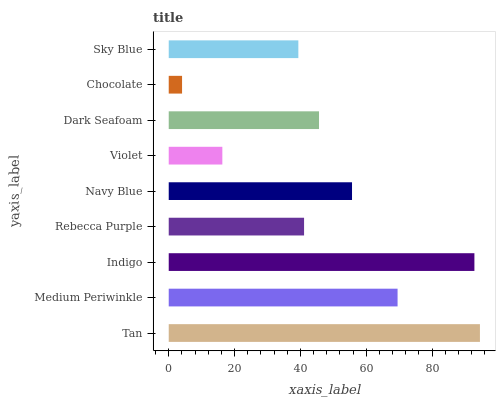Is Chocolate the minimum?
Answer yes or no. Yes. Is Tan the maximum?
Answer yes or no. Yes. Is Medium Periwinkle the minimum?
Answer yes or no. No. Is Medium Periwinkle the maximum?
Answer yes or no. No. Is Tan greater than Medium Periwinkle?
Answer yes or no. Yes. Is Medium Periwinkle less than Tan?
Answer yes or no. Yes. Is Medium Periwinkle greater than Tan?
Answer yes or no. No. Is Tan less than Medium Periwinkle?
Answer yes or no. No. Is Dark Seafoam the high median?
Answer yes or no. Yes. Is Dark Seafoam the low median?
Answer yes or no. Yes. Is Rebecca Purple the high median?
Answer yes or no. No. Is Indigo the low median?
Answer yes or no. No. 